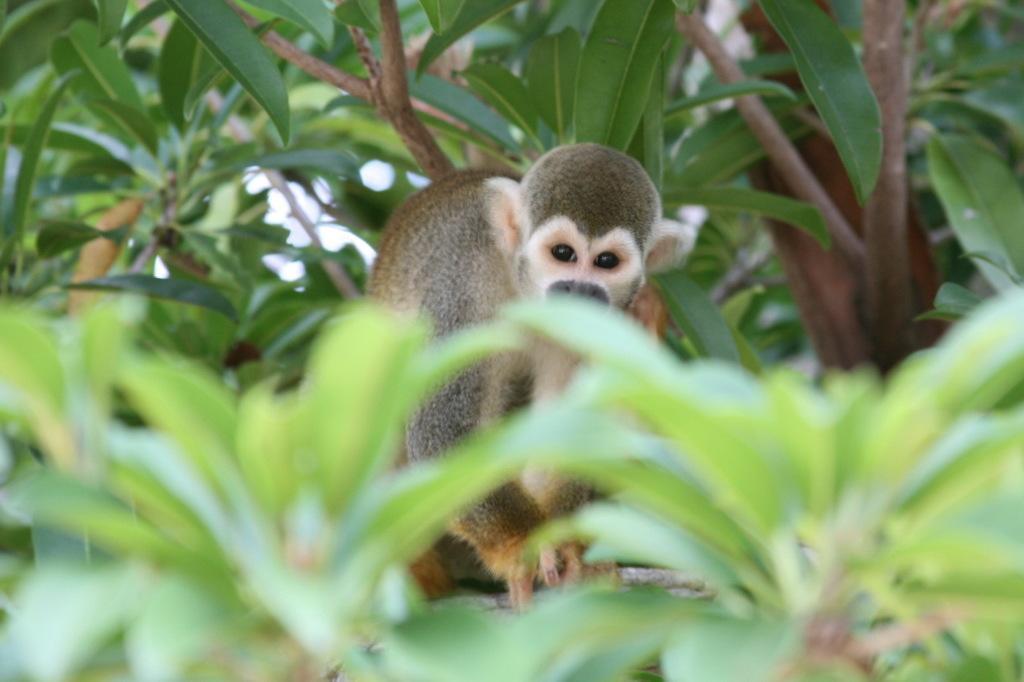In one or two sentences, can you explain what this image depicts? In the center of the image we can see monkey on the tree. 